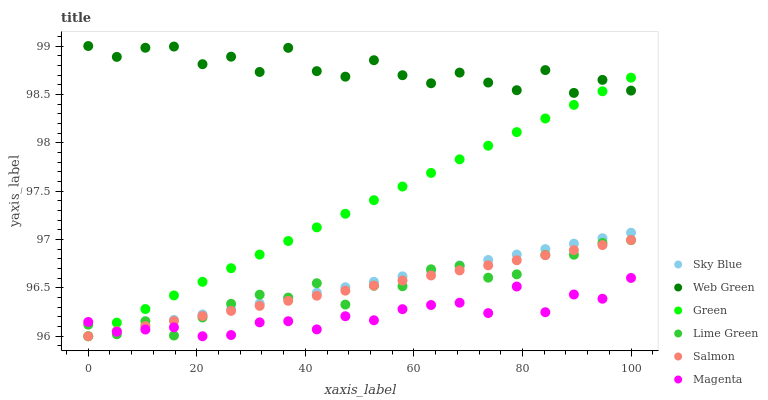Does Magenta have the minimum area under the curve?
Answer yes or no. Yes. Does Web Green have the maximum area under the curve?
Answer yes or no. Yes. Does Green have the minimum area under the curve?
Answer yes or no. No. Does Green have the maximum area under the curve?
Answer yes or no. No. Is Salmon the smoothest?
Answer yes or no. Yes. Is Web Green the roughest?
Answer yes or no. Yes. Is Green the smoothest?
Answer yes or no. No. Is Green the roughest?
Answer yes or no. No. Does Salmon have the lowest value?
Answer yes or no. Yes. Does Web Green have the lowest value?
Answer yes or no. No. Does Web Green have the highest value?
Answer yes or no. Yes. Does Green have the highest value?
Answer yes or no. No. Is Sky Blue less than Web Green?
Answer yes or no. Yes. Is Web Green greater than Sky Blue?
Answer yes or no. Yes. Does Magenta intersect Green?
Answer yes or no. Yes. Is Magenta less than Green?
Answer yes or no. No. Is Magenta greater than Green?
Answer yes or no. No. Does Sky Blue intersect Web Green?
Answer yes or no. No. 